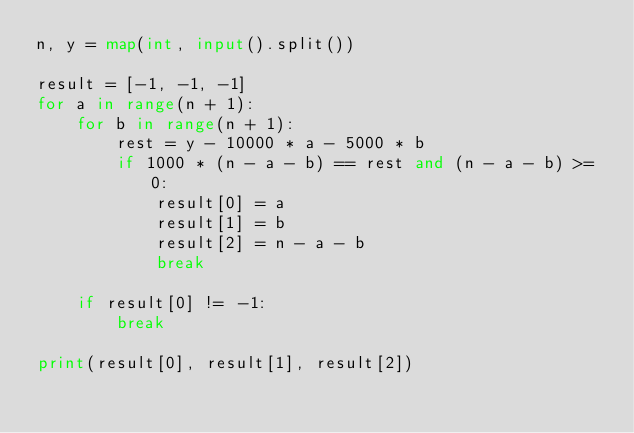Convert code to text. <code><loc_0><loc_0><loc_500><loc_500><_Python_>n, y = map(int, input().split())

result = [-1, -1, -1]
for a in range(n + 1):
    for b in range(n + 1):
        rest = y - 10000 * a - 5000 * b
        if 1000 * (n - a - b) == rest and (n - a - b) >= 0:
            result[0] = a
            result[1] = b
            result[2] = n - a - b
            break

    if result[0] != -1:
        break

print(result[0], result[1], result[2])
</code> 